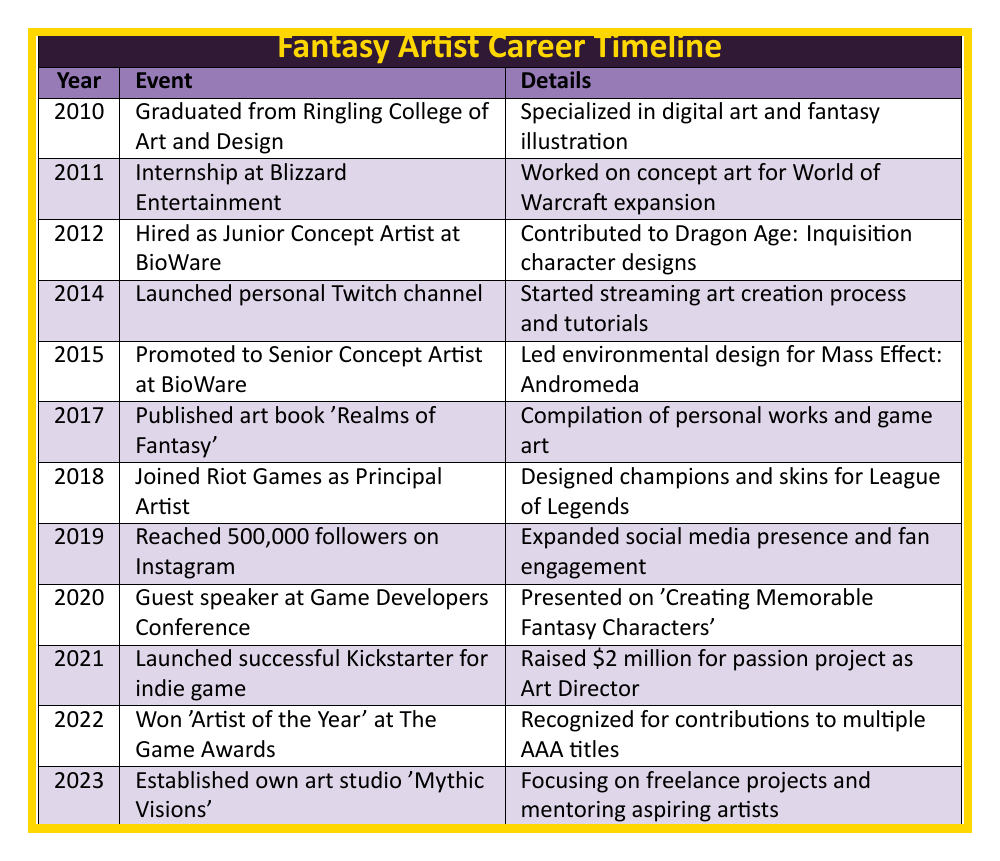What year did the artist graduate from Ringling College? The artist graduated in 2010, as stated in the first row of the table.
Answer: 2010 In which year did the artist reach 500,000 followers on Instagram? According to the table, the artist reached this milestone in 2019, indicated in the relevant row.
Answer: 2019 How many years passed between the artist's graduation and their promotion to Senior Concept Artist at BioWare? The artist graduated in 2010 and was promoted in 2015, which is a difference of 5 years (2015 - 2010 = 5).
Answer: 5 years Did the artist present at the Game Developers Conference? Yes, the table shows that they were a guest speaker at the conference in 2020.
Answer: Yes What was the total number of years from the launch of the Twitch channel to the establishment of the art studio? The Twitch channel was launched in 2014 and the art studio was established in 2023. The difference is 9 years (2023 - 2014 = 9).
Answer: 9 years What is the latest event listed in the timeline? The latest event is the establishment of the artist's own art studio 'Mythic Visions' in 2023, as shown in the last row.
Answer: Established own art studio 'Mythic Visions' How many significant events occurred between 2012 and 2018? In the timeline, there are 5 events listed from 2012 to 2018: 2012 (BioWare), 2014 (Twitch), 2015 (promotion at BioWare), 2017 (art book), and 2018 (Riot Games). Hence, there are 5 significant events.
Answer: 5 events Was the artist recognized at The Game Awards? Yes, the artist won 'Artist of the Year' at The Game Awards in 2022, as stated in the table.
Answer: Yes How many unique companies has the artist worked for according to the timeline? The artist has worked for three different companies: Blizzard Entertainment, BioWare, and Riot Games, as indicated in the respective years.
Answer: 3 companies 